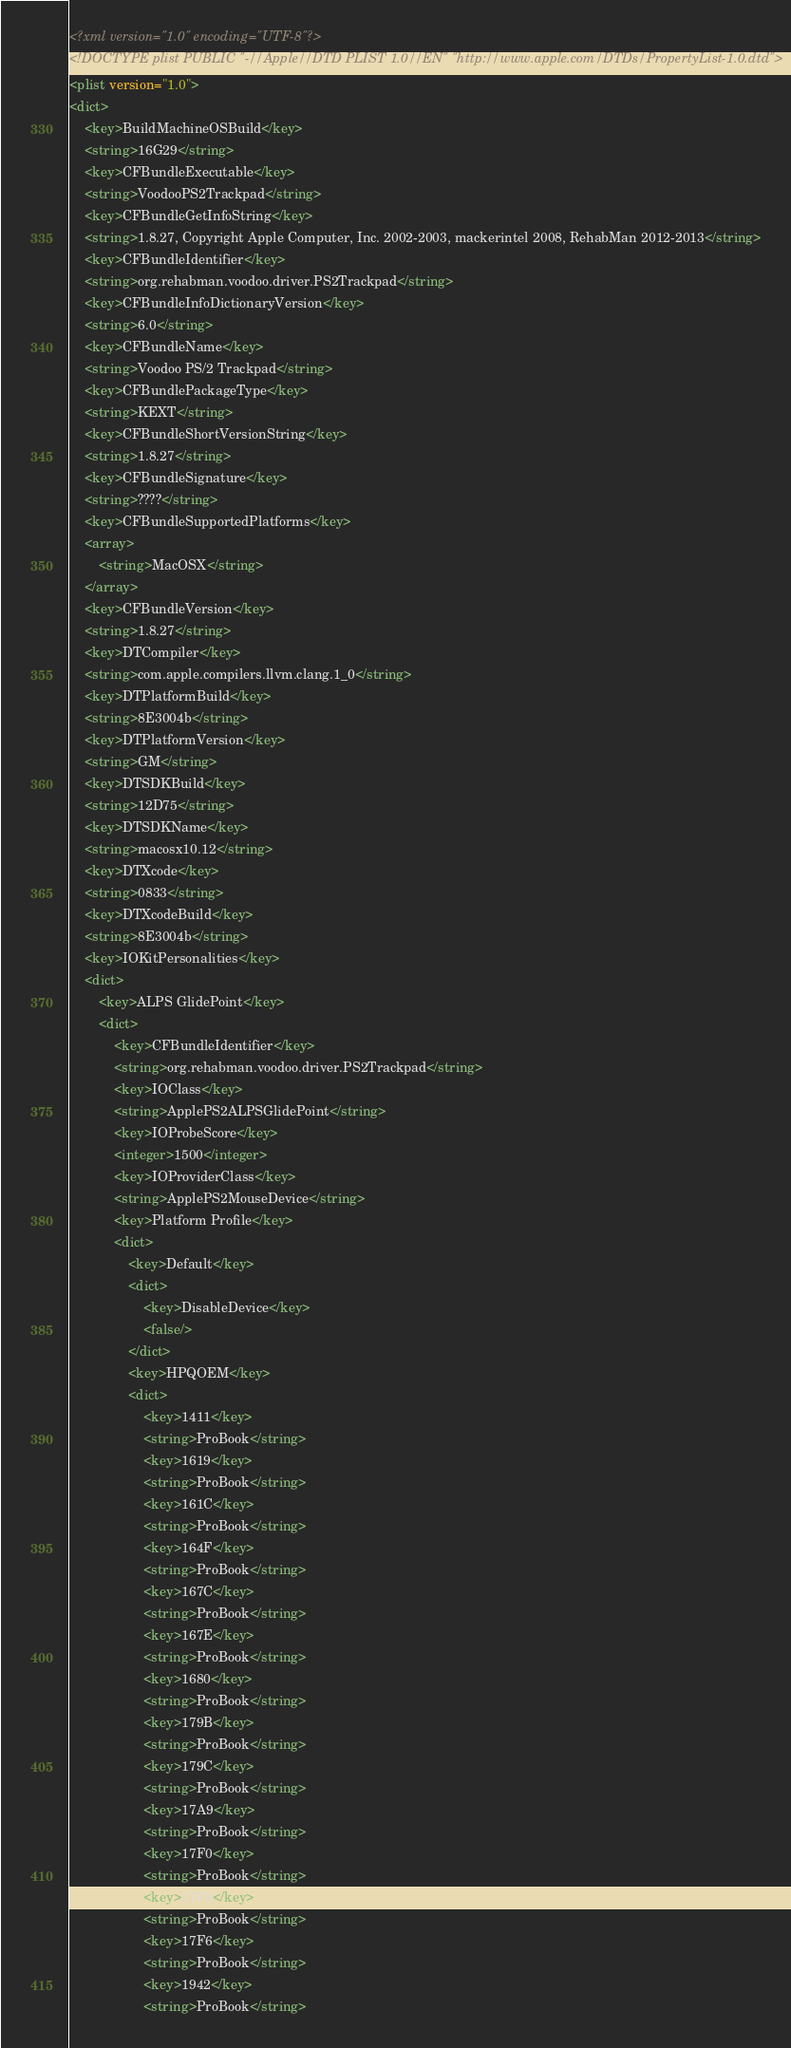<code> <loc_0><loc_0><loc_500><loc_500><_XML_><?xml version="1.0" encoding="UTF-8"?>
<!DOCTYPE plist PUBLIC "-//Apple//DTD PLIST 1.0//EN" "http://www.apple.com/DTDs/PropertyList-1.0.dtd">
<plist version="1.0">
<dict>
	<key>BuildMachineOSBuild</key>
	<string>16G29</string>
	<key>CFBundleExecutable</key>
	<string>VoodooPS2Trackpad</string>
	<key>CFBundleGetInfoString</key>
	<string>1.8.27, Copyright Apple Computer, Inc. 2002-2003, mackerintel 2008, RehabMan 2012-2013</string>
	<key>CFBundleIdentifier</key>
	<string>org.rehabman.voodoo.driver.PS2Trackpad</string>
	<key>CFBundleInfoDictionaryVersion</key>
	<string>6.0</string>
	<key>CFBundleName</key>
	<string>Voodoo PS/2 Trackpad</string>
	<key>CFBundlePackageType</key>
	<string>KEXT</string>
	<key>CFBundleShortVersionString</key>
	<string>1.8.27</string>
	<key>CFBundleSignature</key>
	<string>????</string>
	<key>CFBundleSupportedPlatforms</key>
	<array>
		<string>MacOSX</string>
	</array>
	<key>CFBundleVersion</key>
	<string>1.8.27</string>
	<key>DTCompiler</key>
	<string>com.apple.compilers.llvm.clang.1_0</string>
	<key>DTPlatformBuild</key>
	<string>8E3004b</string>
	<key>DTPlatformVersion</key>
	<string>GM</string>
	<key>DTSDKBuild</key>
	<string>12D75</string>
	<key>DTSDKName</key>
	<string>macosx10.12</string>
	<key>DTXcode</key>
	<string>0833</string>
	<key>DTXcodeBuild</key>
	<string>8E3004b</string>
	<key>IOKitPersonalities</key>
	<dict>
		<key>ALPS GlidePoint</key>
		<dict>
			<key>CFBundleIdentifier</key>
			<string>org.rehabman.voodoo.driver.PS2Trackpad</string>
			<key>IOClass</key>
			<string>ApplePS2ALPSGlidePoint</string>
			<key>IOProbeScore</key>
			<integer>1500</integer>
			<key>IOProviderClass</key>
			<string>ApplePS2MouseDevice</string>
			<key>Platform Profile</key>
			<dict>
				<key>Default</key>
				<dict>
					<key>DisableDevice</key>
					<false/>
				</dict>
				<key>HPQOEM</key>
				<dict>
					<key>1411</key>
					<string>ProBook</string>
					<key>1619</key>
					<string>ProBook</string>
					<key>161C</key>
					<string>ProBook</string>
					<key>164F</key>
					<string>ProBook</string>
					<key>167C</key>
					<string>ProBook</string>
					<key>167E</key>
					<string>ProBook</string>
					<key>1680</key>
					<string>ProBook</string>
					<key>179B</key>
					<string>ProBook</string>
					<key>179C</key>
					<string>ProBook</string>
					<key>17A9</key>
					<string>ProBook</string>
					<key>17F0</key>
					<string>ProBook</string>
					<key>17F3</key>
					<string>ProBook</string>
					<key>17F6</key>
					<string>ProBook</string>
					<key>1942</key>
					<string>ProBook</string></code> 